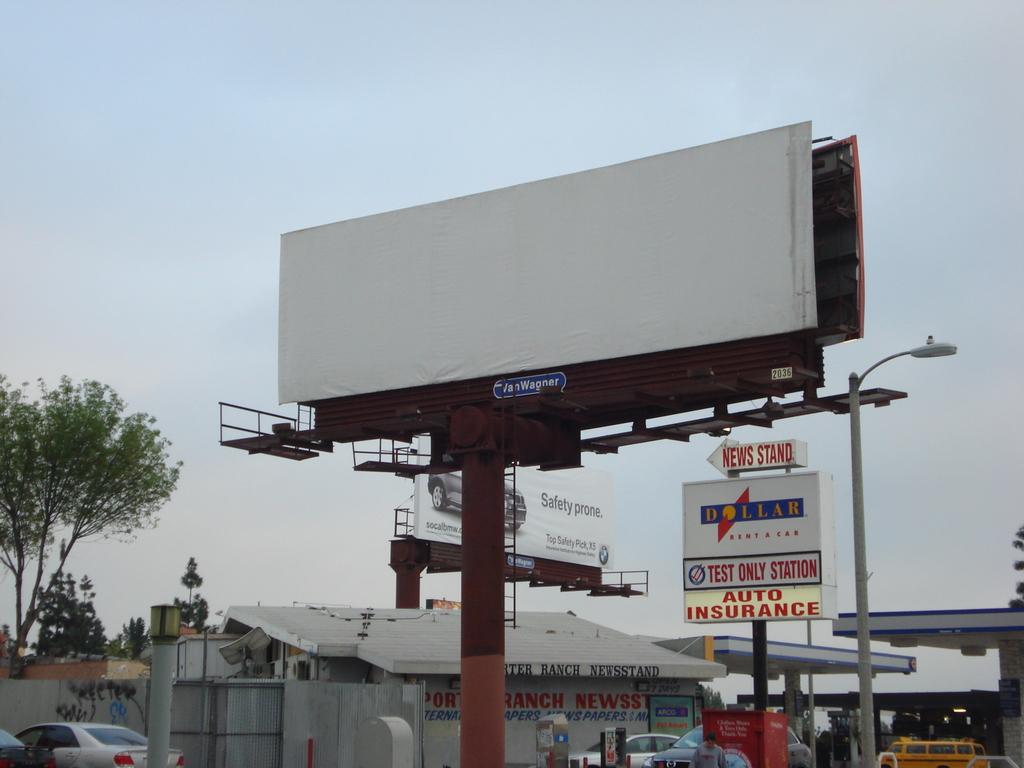What kind of insurance is offered here?
Your response must be concise. Auto. What company has the auto insurance?
Make the answer very short. Dollar. 